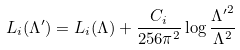Convert formula to latex. <formula><loc_0><loc_0><loc_500><loc_500>L _ { i } ( \Lambda ^ { \prime } ) = L _ { i } ( \Lambda ) + \frac { C _ { i } } { 2 5 6 \pi ^ { 2 } } \log \frac { { \Lambda ^ { \prime } } ^ { 2 } } { \Lambda ^ { 2 } }</formula> 